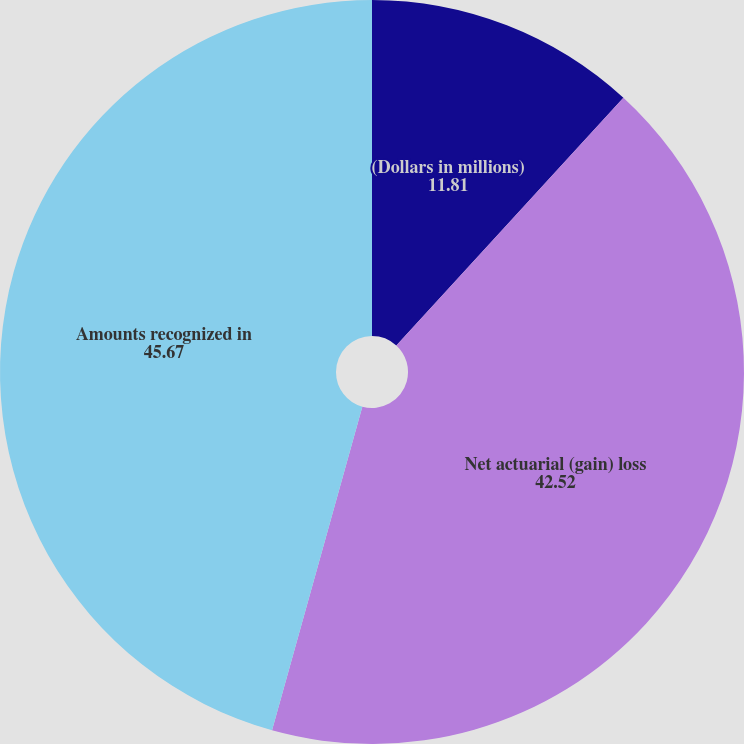Convert chart to OTSL. <chart><loc_0><loc_0><loc_500><loc_500><pie_chart><fcel>(Dollars in millions)<fcel>Net actuarial (gain) loss<fcel>Amounts recognized in<nl><fcel>11.81%<fcel>42.52%<fcel>45.67%<nl></chart> 